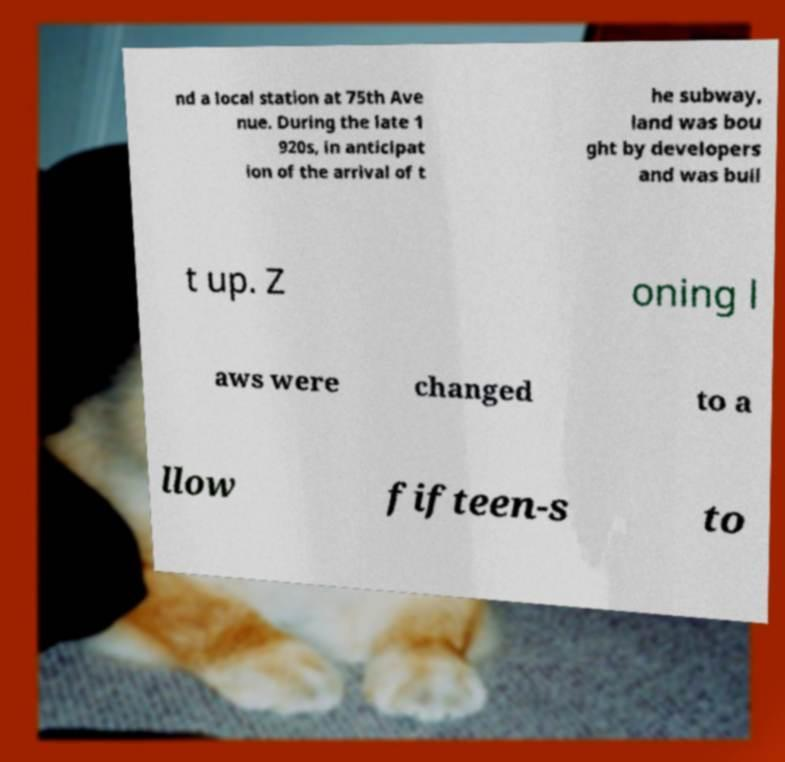Can you read and provide the text displayed in the image?This photo seems to have some interesting text. Can you extract and type it out for me? nd a local station at 75th Ave nue. During the late 1 920s, in anticipat ion of the arrival of t he subway, land was bou ght by developers and was buil t up. Z oning l aws were changed to a llow fifteen-s to 